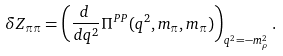Convert formula to latex. <formula><loc_0><loc_0><loc_500><loc_500>\delta Z _ { \pi \pi } = \left ( \frac { d \, } { d q ^ { 2 } } \Pi ^ { P P } ( q ^ { 2 } , m _ { \pi } , m _ { \pi } ) \right ) _ { q ^ { 2 } = - m _ { \rho } ^ { 2 } } .</formula> 